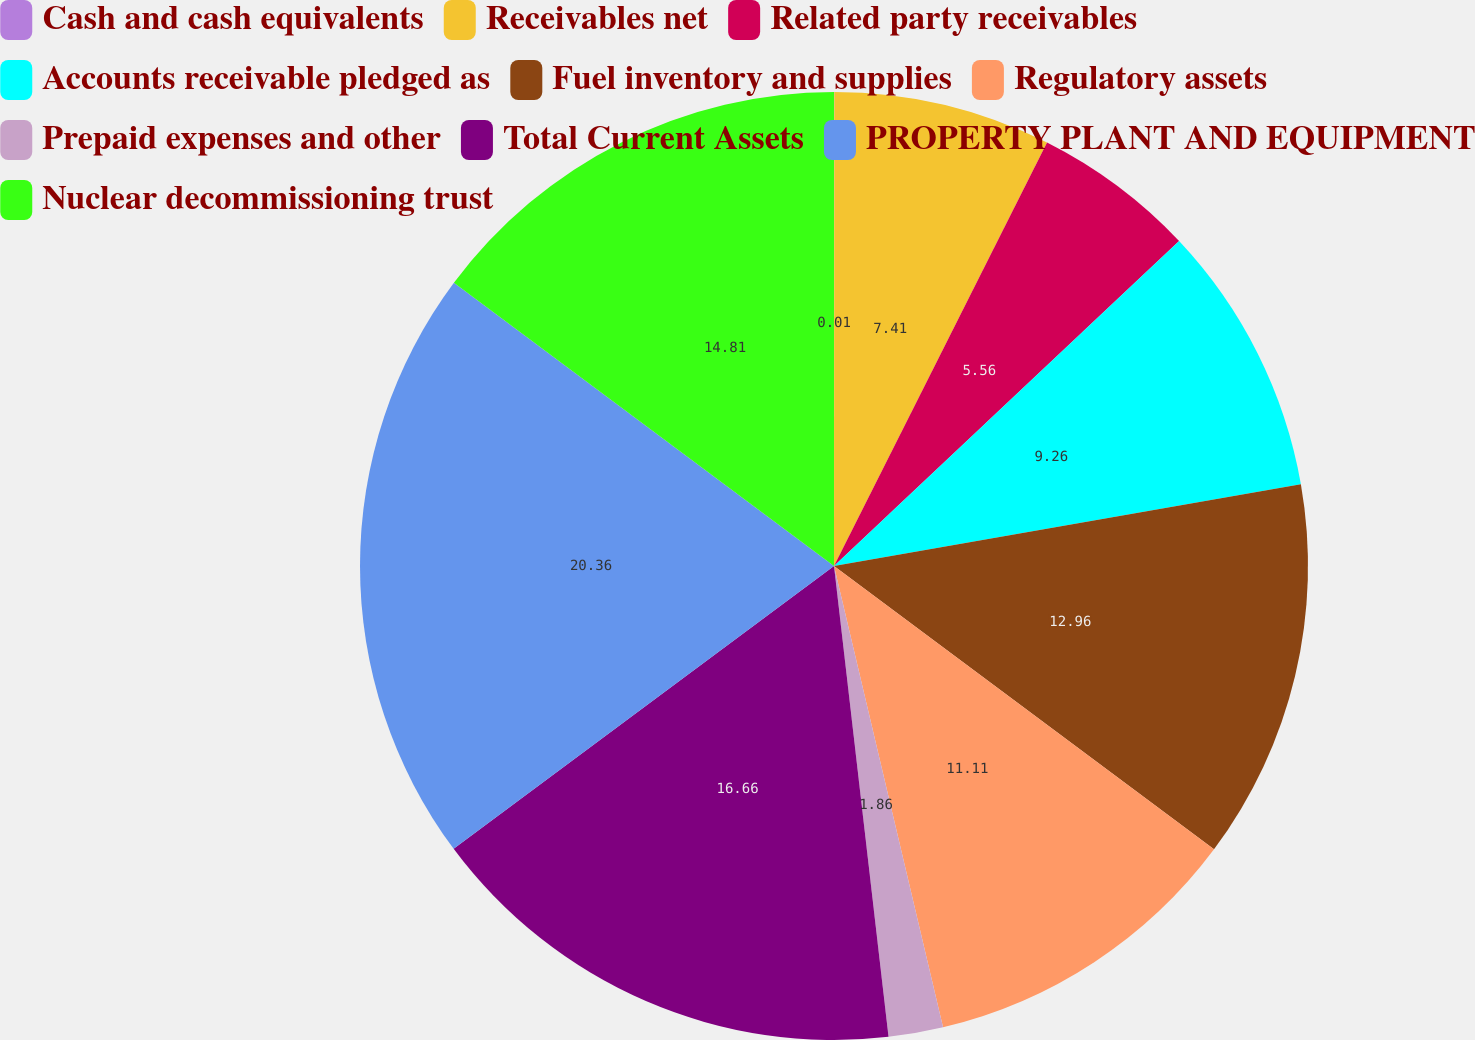<chart> <loc_0><loc_0><loc_500><loc_500><pie_chart><fcel>Cash and cash equivalents<fcel>Receivables net<fcel>Related party receivables<fcel>Accounts receivable pledged as<fcel>Fuel inventory and supplies<fcel>Regulatory assets<fcel>Prepaid expenses and other<fcel>Total Current Assets<fcel>PROPERTY PLANT AND EQUIPMENT<fcel>Nuclear decommissioning trust<nl><fcel>0.01%<fcel>7.41%<fcel>5.56%<fcel>9.26%<fcel>12.96%<fcel>11.11%<fcel>1.86%<fcel>16.66%<fcel>20.37%<fcel>14.81%<nl></chart> 